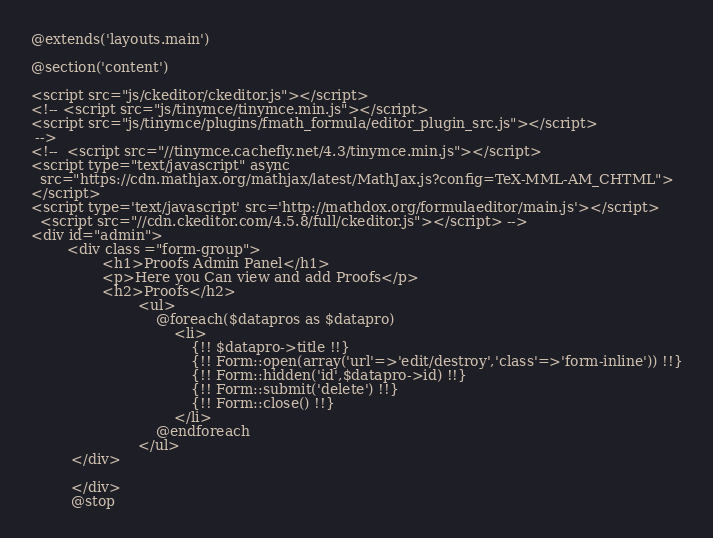Convert code to text. <code><loc_0><loc_0><loc_500><loc_500><_PHP_>@extends('layouts.main')

@section('content')

<script src="js/ckeditor/ckeditor.js"></script>
<!-- <script src="js/tinymce/tinymce.min.js"></script>
<script src="js/tinymce/plugins/fmath_formula/editor_plugin_src.js"></script>
 -->
<!--  <script src="//tinymce.cachefly.net/4.3/tinymce.min.js"></script>
<script type="text/javascript" async
  src="https://cdn.mathjax.org/mathjax/latest/MathJax.js?config=TeX-MML-AM_CHTML">
</script>
<script type='text/javascript' src='http://mathdox.org/formulaeditor/main.js'></script>
  <script src="//cdn.ckeditor.com/4.5.8/full/ckeditor.js"></script> -->
<div id="admin">
		<div class ="form-group">
				<h1>Proofs Admin Panel</h1>
				<p>Here you Can view and add Proofs</p>
				<h2>Proofs</h2>
						<ul>
							@foreach($datapros as $datapro)
								<li>
									{!! $datapro->title !!}
									{!! Form::open(array('url'=>'edit/destroy','class'=>'form-inline')) !!}
									{!! Form::hidden('id',$datapro->id) !!}
									{!! Form::submit('delete') !!}
									{!! Form::close() !!}
								</li>
							@endforeach
						</ul>
		 </div>
		
		 </div>
		 @stop</code> 